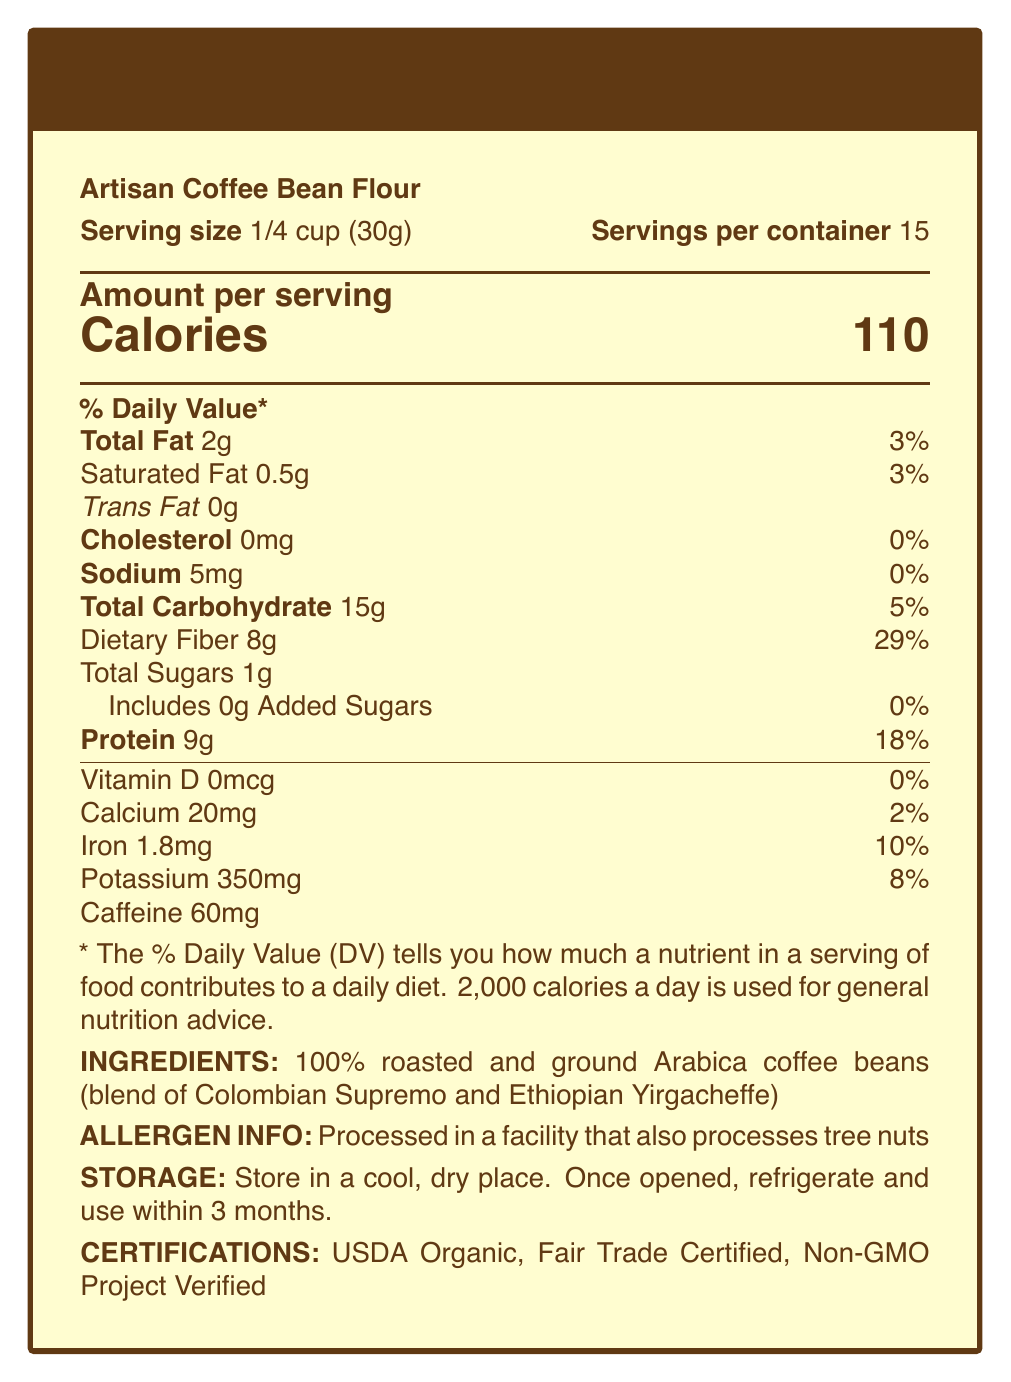What is the protein content per serving? The document indicates that each serving contains 9 grams of protein.
Answer: 9g How many grams of dietary fiber are in one serving? According to the document, there are 8 grams of dietary fiber in each serving.
Answer: 8g What is the serving size for Artisan Coffee Bean Flour? The document states that the serving size is 1/4 cup (30 grams).
Answer: 1/4 cup (30g) How many servings are in one container? The document specifies that there are 15 servings per container.
Answer: 15 What is the percentage of Daily Value for protein in one serving? The document indicates that one serving provides 18% of the Daily Value for protein.
Answer: 18% Which nutrient has the highest percentage of the Daily Value per serving? A. Vitamin D B. Iron C. Dietary Fiber D. Protein The document shows that Dietary Fiber has the highest percentage of Daily Value at 29%.
Answer: C. Dietary Fiber What is the amount of caffeine in one serving? A. 30mg B. 45mg C. 60mg D. 75mg The document specifies that there are 60 milligrams of caffeine per serving.
Answer: C. 60mg Does the Artisan Coffee Bean Flour contain any cholesterol? The document indicates that the cholesterol content is 0mg.
Answer: No What are some of the suggested uses for Artisan Coffee Bean Flour? The document lists these usage suggestions for Artisan Coffee Bean Flour.
Answer: Creating protein-rich smoothies, baking low-carb treats, or as a unique coating for savory dishes Is there any information about allergens in this product? The document states that it is processed in a facility that also processes tree nuts.
Answer: Yes Can you determine the retail price of Artisan Coffee Bean Flour from this document? The document does not provide any pricing details.
Answer: Not enough information Summarize the main nutritional attributes of Artisan Coffee Bean Flour. The document highlights that each serving of Artisan Coffee Bean Flour has significant amounts of protein (9 grams) and dietary fiber (8 grams), contributing to 18% and 29% of the Daily Value, respectively. It is also low in total fat (2 grams) and sodium (5 milligrams), making it a nutritious choice for different culinary uses.
Answer: Artisan Coffee Bean Flour provides a high protein (9g) and dietary fiber (8g) content per serving, with low fat (2g) and sodium (5mg), making it a nutrient-rich addition to various recipes. 